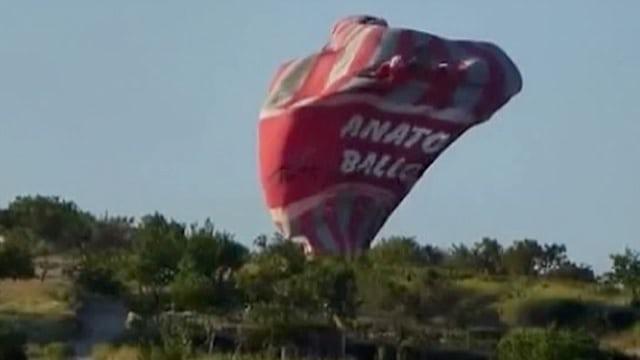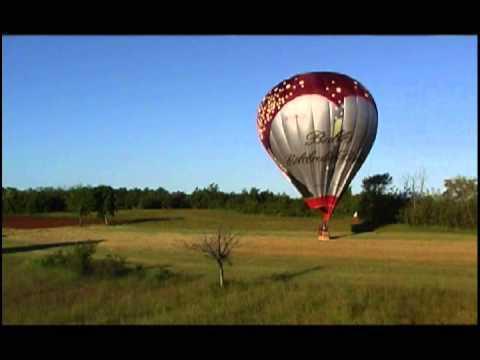The first image is the image on the left, the second image is the image on the right. Examine the images to the left and right. Is the description "In the left image, there is a single balloon that is red, white and blue." accurate? Answer yes or no. No. The first image is the image on the left, the second image is the image on the right. Analyze the images presented: Is the assertion "One image shows a red, white and blue balloon with stripes, and the other shows a multicolored striped balloon with at least six colors." valid? Answer yes or no. No. 